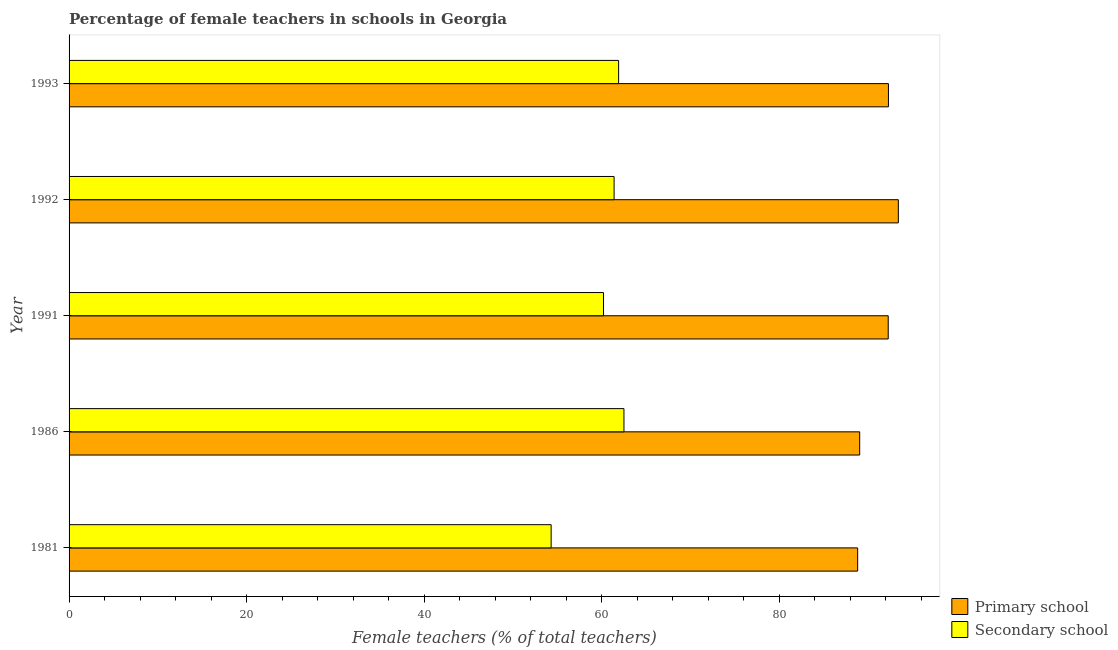How many different coloured bars are there?
Ensure brevity in your answer.  2. Are the number of bars per tick equal to the number of legend labels?
Provide a succinct answer. Yes. How many bars are there on the 5th tick from the top?
Offer a terse response. 2. What is the percentage of female teachers in secondary schools in 1981?
Provide a short and direct response. 54.29. Across all years, what is the maximum percentage of female teachers in secondary schools?
Give a very brief answer. 62.49. Across all years, what is the minimum percentage of female teachers in primary schools?
Ensure brevity in your answer.  88.82. What is the total percentage of female teachers in secondary schools in the graph?
Give a very brief answer. 300.26. What is the difference between the percentage of female teachers in primary schools in 1993 and the percentage of female teachers in secondary schools in 1981?
Keep it short and to the point. 37.99. What is the average percentage of female teachers in primary schools per year?
Offer a terse response. 91.16. In the year 1992, what is the difference between the percentage of female teachers in secondary schools and percentage of female teachers in primary schools?
Give a very brief answer. -32.01. What is the ratio of the percentage of female teachers in secondary schools in 1981 to that in 1993?
Ensure brevity in your answer.  0.88. Is the difference between the percentage of female teachers in primary schools in 1981 and 1991 greater than the difference between the percentage of female teachers in secondary schools in 1981 and 1991?
Keep it short and to the point. Yes. What is the difference between the highest and the second highest percentage of female teachers in secondary schools?
Ensure brevity in your answer.  0.6. What is the difference between the highest and the lowest percentage of female teachers in primary schools?
Your response must be concise. 4.58. Is the sum of the percentage of female teachers in primary schools in 1981 and 1991 greater than the maximum percentage of female teachers in secondary schools across all years?
Make the answer very short. Yes. What does the 1st bar from the top in 1991 represents?
Offer a very short reply. Secondary school. What does the 1st bar from the bottom in 1986 represents?
Offer a very short reply. Primary school. How many bars are there?
Your answer should be very brief. 10. Are all the bars in the graph horizontal?
Your answer should be compact. Yes. What is the difference between two consecutive major ticks on the X-axis?
Provide a succinct answer. 20. Are the values on the major ticks of X-axis written in scientific E-notation?
Offer a very short reply. No. Does the graph contain any zero values?
Provide a succinct answer. No. Where does the legend appear in the graph?
Provide a short and direct response. Bottom right. How are the legend labels stacked?
Your response must be concise. Vertical. What is the title of the graph?
Provide a short and direct response. Percentage of female teachers in schools in Georgia. Does "Arms exports" appear as one of the legend labels in the graph?
Your answer should be compact. No. What is the label or title of the X-axis?
Your answer should be compact. Female teachers (% of total teachers). What is the Female teachers (% of total teachers) of Primary school in 1981?
Give a very brief answer. 88.82. What is the Female teachers (% of total teachers) in Secondary school in 1981?
Your answer should be very brief. 54.29. What is the Female teachers (% of total teachers) of Primary school in 1986?
Provide a short and direct response. 89.05. What is the Female teachers (% of total teachers) in Secondary school in 1986?
Offer a terse response. 62.49. What is the Female teachers (% of total teachers) of Primary school in 1991?
Your response must be concise. 92.26. What is the Female teachers (% of total teachers) of Secondary school in 1991?
Ensure brevity in your answer.  60.19. What is the Female teachers (% of total teachers) of Primary school in 1992?
Offer a terse response. 93.4. What is the Female teachers (% of total teachers) of Secondary school in 1992?
Keep it short and to the point. 61.38. What is the Female teachers (% of total teachers) in Primary school in 1993?
Provide a succinct answer. 92.28. What is the Female teachers (% of total teachers) in Secondary school in 1993?
Give a very brief answer. 61.89. Across all years, what is the maximum Female teachers (% of total teachers) of Primary school?
Offer a terse response. 93.4. Across all years, what is the maximum Female teachers (% of total teachers) in Secondary school?
Keep it short and to the point. 62.49. Across all years, what is the minimum Female teachers (% of total teachers) in Primary school?
Give a very brief answer. 88.82. Across all years, what is the minimum Female teachers (% of total teachers) in Secondary school?
Your response must be concise. 54.29. What is the total Female teachers (% of total teachers) in Primary school in the graph?
Your answer should be compact. 455.8. What is the total Female teachers (% of total teachers) of Secondary school in the graph?
Give a very brief answer. 300.26. What is the difference between the Female teachers (% of total teachers) in Primary school in 1981 and that in 1986?
Your response must be concise. -0.23. What is the difference between the Female teachers (% of total teachers) in Secondary school in 1981 and that in 1986?
Ensure brevity in your answer.  -8.2. What is the difference between the Female teachers (% of total teachers) of Primary school in 1981 and that in 1991?
Provide a succinct answer. -3.44. What is the difference between the Female teachers (% of total teachers) of Secondary school in 1981 and that in 1991?
Offer a terse response. -5.9. What is the difference between the Female teachers (% of total teachers) of Primary school in 1981 and that in 1992?
Offer a terse response. -4.58. What is the difference between the Female teachers (% of total teachers) in Secondary school in 1981 and that in 1992?
Provide a succinct answer. -7.09. What is the difference between the Female teachers (% of total teachers) in Primary school in 1981 and that in 1993?
Your answer should be very brief. -3.47. What is the difference between the Female teachers (% of total teachers) in Secondary school in 1981 and that in 1993?
Your response must be concise. -7.6. What is the difference between the Female teachers (% of total teachers) of Primary school in 1986 and that in 1991?
Give a very brief answer. -3.21. What is the difference between the Female teachers (% of total teachers) of Secondary school in 1986 and that in 1991?
Keep it short and to the point. 2.3. What is the difference between the Female teachers (% of total teachers) in Primary school in 1986 and that in 1992?
Your response must be concise. -4.35. What is the difference between the Female teachers (% of total teachers) in Secondary school in 1986 and that in 1992?
Provide a short and direct response. 1.11. What is the difference between the Female teachers (% of total teachers) in Primary school in 1986 and that in 1993?
Provide a succinct answer. -3.24. What is the difference between the Female teachers (% of total teachers) in Secondary school in 1986 and that in 1993?
Your answer should be very brief. 0.6. What is the difference between the Female teachers (% of total teachers) in Primary school in 1991 and that in 1992?
Your response must be concise. -1.14. What is the difference between the Female teachers (% of total teachers) in Secondary school in 1991 and that in 1992?
Your answer should be compact. -1.19. What is the difference between the Female teachers (% of total teachers) of Primary school in 1991 and that in 1993?
Keep it short and to the point. -0.02. What is the difference between the Female teachers (% of total teachers) in Secondary school in 1991 and that in 1993?
Offer a very short reply. -1.7. What is the difference between the Female teachers (% of total teachers) of Primary school in 1992 and that in 1993?
Offer a very short reply. 1.12. What is the difference between the Female teachers (% of total teachers) in Secondary school in 1992 and that in 1993?
Keep it short and to the point. -0.51. What is the difference between the Female teachers (% of total teachers) of Primary school in 1981 and the Female teachers (% of total teachers) of Secondary school in 1986?
Give a very brief answer. 26.32. What is the difference between the Female teachers (% of total teachers) in Primary school in 1981 and the Female teachers (% of total teachers) in Secondary school in 1991?
Ensure brevity in your answer.  28.63. What is the difference between the Female teachers (% of total teachers) in Primary school in 1981 and the Female teachers (% of total teachers) in Secondary school in 1992?
Give a very brief answer. 27.43. What is the difference between the Female teachers (% of total teachers) in Primary school in 1981 and the Female teachers (% of total teachers) in Secondary school in 1993?
Your answer should be compact. 26.92. What is the difference between the Female teachers (% of total teachers) in Primary school in 1986 and the Female teachers (% of total teachers) in Secondary school in 1991?
Give a very brief answer. 28.85. What is the difference between the Female teachers (% of total teachers) in Primary school in 1986 and the Female teachers (% of total teachers) in Secondary school in 1992?
Provide a short and direct response. 27.66. What is the difference between the Female teachers (% of total teachers) in Primary school in 1986 and the Female teachers (% of total teachers) in Secondary school in 1993?
Ensure brevity in your answer.  27.15. What is the difference between the Female teachers (% of total teachers) of Primary school in 1991 and the Female teachers (% of total teachers) of Secondary school in 1992?
Ensure brevity in your answer.  30.87. What is the difference between the Female teachers (% of total teachers) in Primary school in 1991 and the Female teachers (% of total teachers) in Secondary school in 1993?
Keep it short and to the point. 30.37. What is the difference between the Female teachers (% of total teachers) in Primary school in 1992 and the Female teachers (% of total teachers) in Secondary school in 1993?
Your response must be concise. 31.51. What is the average Female teachers (% of total teachers) of Primary school per year?
Your answer should be very brief. 91.16. What is the average Female teachers (% of total teachers) in Secondary school per year?
Your response must be concise. 60.05. In the year 1981, what is the difference between the Female teachers (% of total teachers) in Primary school and Female teachers (% of total teachers) in Secondary school?
Your response must be concise. 34.52. In the year 1986, what is the difference between the Female teachers (% of total teachers) of Primary school and Female teachers (% of total teachers) of Secondary school?
Make the answer very short. 26.55. In the year 1991, what is the difference between the Female teachers (% of total teachers) of Primary school and Female teachers (% of total teachers) of Secondary school?
Your answer should be very brief. 32.07. In the year 1992, what is the difference between the Female teachers (% of total teachers) in Primary school and Female teachers (% of total teachers) in Secondary school?
Provide a succinct answer. 32.01. In the year 1993, what is the difference between the Female teachers (% of total teachers) of Primary school and Female teachers (% of total teachers) of Secondary school?
Ensure brevity in your answer.  30.39. What is the ratio of the Female teachers (% of total teachers) in Secondary school in 1981 to that in 1986?
Your answer should be compact. 0.87. What is the ratio of the Female teachers (% of total teachers) in Primary school in 1981 to that in 1991?
Ensure brevity in your answer.  0.96. What is the ratio of the Female teachers (% of total teachers) of Secondary school in 1981 to that in 1991?
Provide a short and direct response. 0.9. What is the ratio of the Female teachers (% of total teachers) of Primary school in 1981 to that in 1992?
Offer a very short reply. 0.95. What is the ratio of the Female teachers (% of total teachers) of Secondary school in 1981 to that in 1992?
Offer a terse response. 0.88. What is the ratio of the Female teachers (% of total teachers) of Primary school in 1981 to that in 1993?
Your answer should be very brief. 0.96. What is the ratio of the Female teachers (% of total teachers) in Secondary school in 1981 to that in 1993?
Keep it short and to the point. 0.88. What is the ratio of the Female teachers (% of total teachers) of Primary school in 1986 to that in 1991?
Provide a succinct answer. 0.97. What is the ratio of the Female teachers (% of total teachers) in Secondary school in 1986 to that in 1991?
Ensure brevity in your answer.  1.04. What is the ratio of the Female teachers (% of total teachers) in Primary school in 1986 to that in 1992?
Ensure brevity in your answer.  0.95. What is the ratio of the Female teachers (% of total teachers) of Secondary school in 1986 to that in 1992?
Ensure brevity in your answer.  1.02. What is the ratio of the Female teachers (% of total teachers) in Primary school in 1986 to that in 1993?
Ensure brevity in your answer.  0.96. What is the ratio of the Female teachers (% of total teachers) in Secondary school in 1986 to that in 1993?
Your answer should be very brief. 1.01. What is the ratio of the Female teachers (% of total teachers) in Secondary school in 1991 to that in 1992?
Your response must be concise. 0.98. What is the ratio of the Female teachers (% of total teachers) of Primary school in 1991 to that in 1993?
Provide a short and direct response. 1. What is the ratio of the Female teachers (% of total teachers) of Secondary school in 1991 to that in 1993?
Provide a succinct answer. 0.97. What is the ratio of the Female teachers (% of total teachers) of Primary school in 1992 to that in 1993?
Your answer should be very brief. 1.01. What is the ratio of the Female teachers (% of total teachers) of Secondary school in 1992 to that in 1993?
Your answer should be very brief. 0.99. What is the difference between the highest and the second highest Female teachers (% of total teachers) in Primary school?
Offer a terse response. 1.12. What is the difference between the highest and the second highest Female teachers (% of total teachers) in Secondary school?
Provide a short and direct response. 0.6. What is the difference between the highest and the lowest Female teachers (% of total teachers) of Primary school?
Make the answer very short. 4.58. What is the difference between the highest and the lowest Female teachers (% of total teachers) of Secondary school?
Your answer should be very brief. 8.2. 